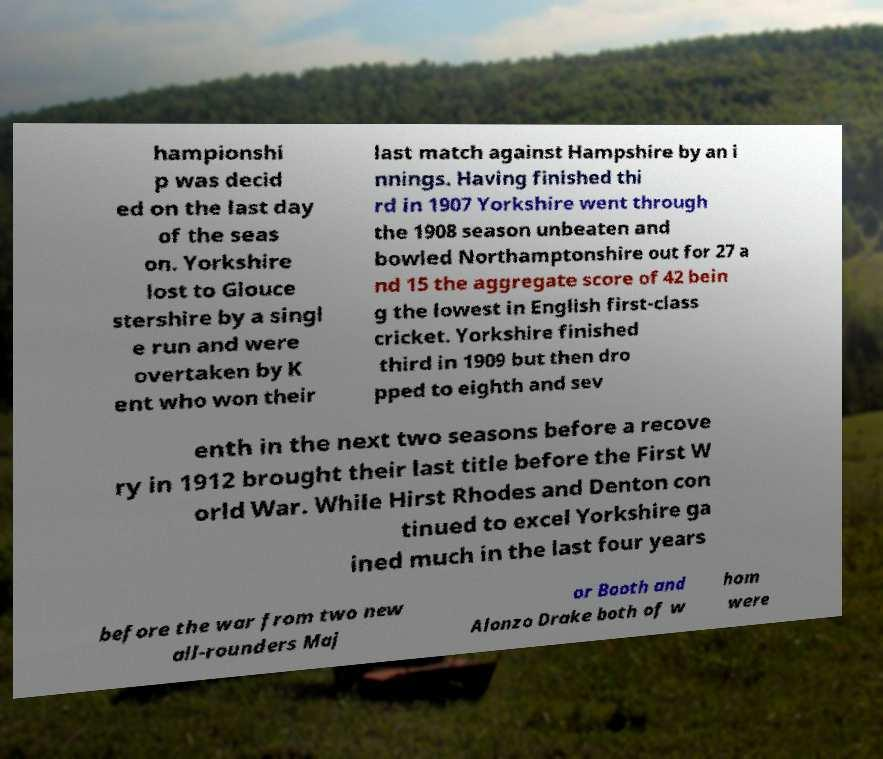There's text embedded in this image that I need extracted. Can you transcribe it verbatim? hampionshi p was decid ed on the last day of the seas on. Yorkshire lost to Glouce stershire by a singl e run and were overtaken by K ent who won their last match against Hampshire by an i nnings. Having finished thi rd in 1907 Yorkshire went through the 1908 season unbeaten and bowled Northamptonshire out for 27 a nd 15 the aggregate score of 42 bein g the lowest in English first-class cricket. Yorkshire finished third in 1909 but then dro pped to eighth and sev enth in the next two seasons before a recove ry in 1912 brought their last title before the First W orld War. While Hirst Rhodes and Denton con tinued to excel Yorkshire ga ined much in the last four years before the war from two new all-rounders Maj or Booth and Alonzo Drake both of w hom were 